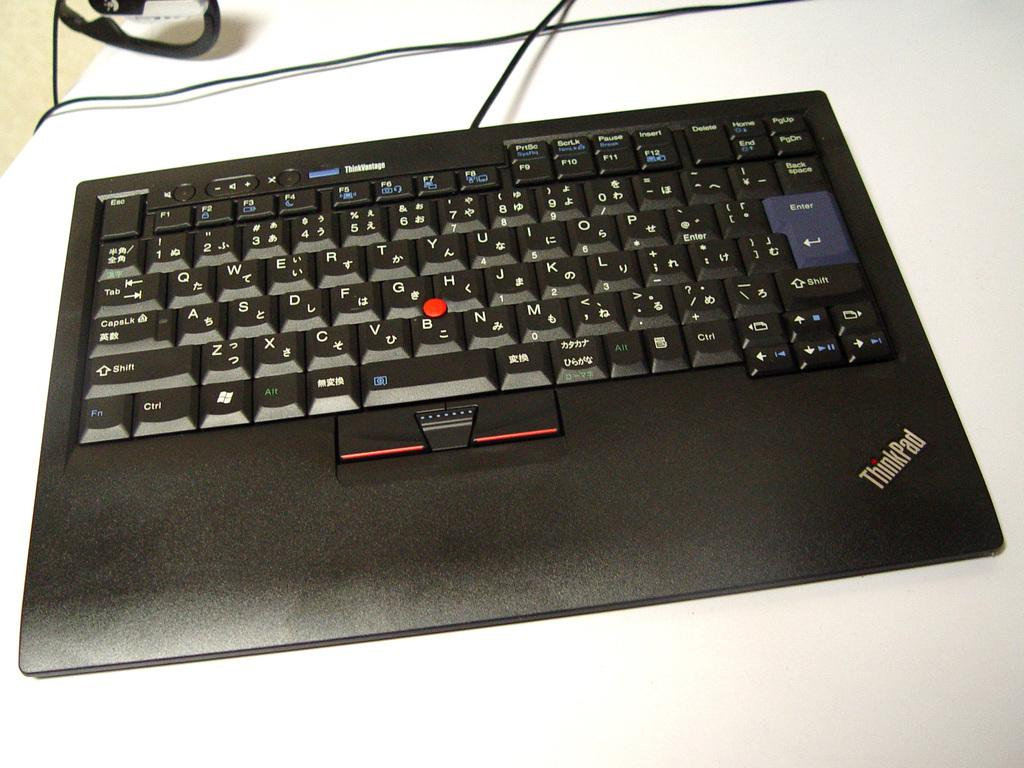What type of keyboard is visible in the image? There is a black color keyboard in the image. What is the color of the table on which the keyboard is placed? The keyboard is on a white table. What type of attraction can be seen in the background of the image? There is no background or attraction visible in the image; it only shows a black color keyboard on a white table. 